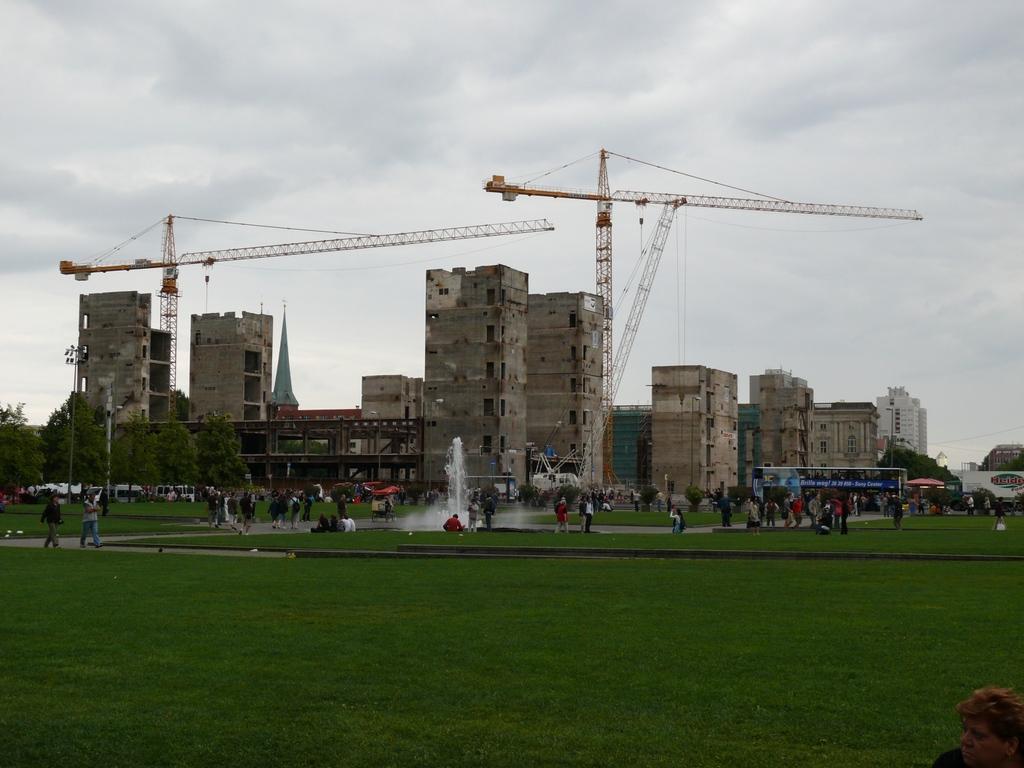Describe this image in one or two sentences. In this image there is a park, in that park there are walking paths, people are doing different activities in the park and there is a fountain, in the back ground there are trees and some houses are constructing and there is cloudy sky. 